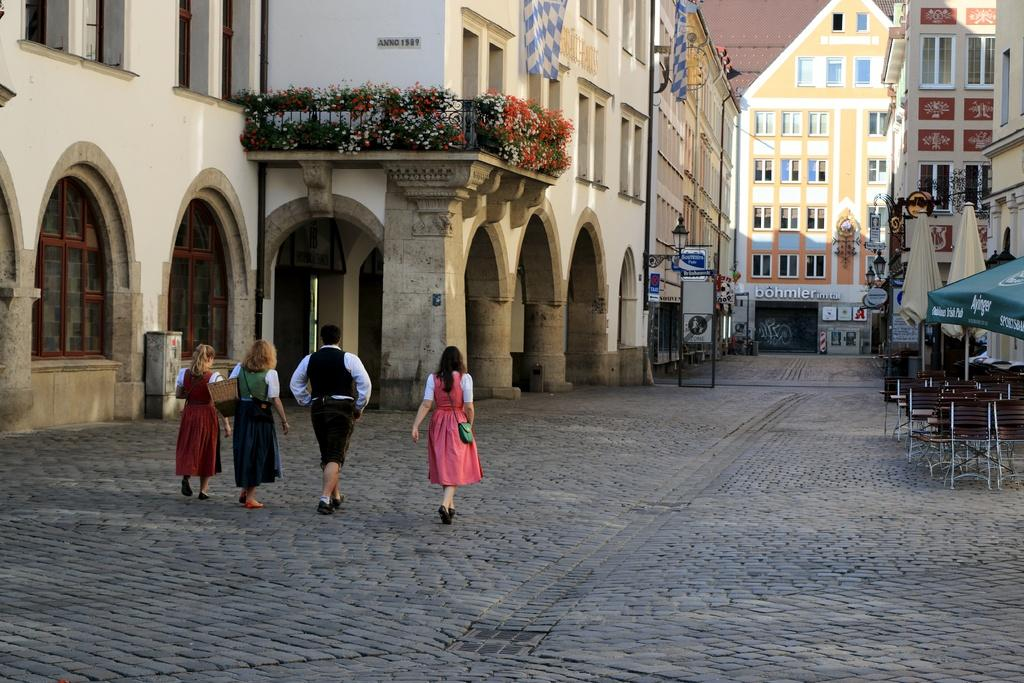How many people are in the image? There are four persons standing in the image. What type of structures can be seen in the image? There are buildings in the image. What type of furniture is present in the image? Chairs and tables are visible in the image. What type of weather protection is available in the image? Umbrellas and a canopy tent are in the image. What type of lighting is present in the image? Lights are present in the image. What type of signage is in the image? Boards and banners are visible in the image. Where is the rabbit hiding in the image? There is no rabbit present in the image. What type of arch can be seen in the image? There is no arch present in the image. 